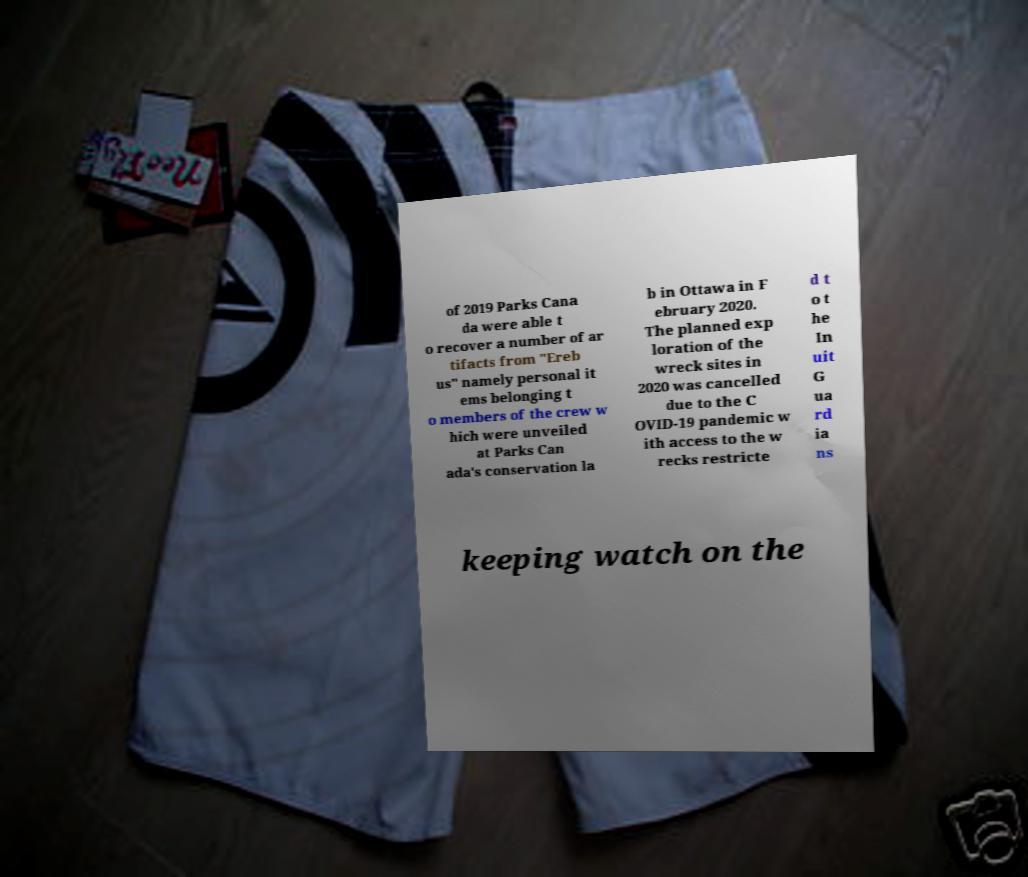Could you assist in decoding the text presented in this image and type it out clearly? of 2019 Parks Cana da were able t o recover a number of ar tifacts from "Ereb us" namely personal it ems belonging t o members of the crew w hich were unveiled at Parks Can ada's conservation la b in Ottawa in F ebruary 2020. The planned exp loration of the wreck sites in 2020 was cancelled due to the C OVID-19 pandemic w ith access to the w recks restricte d t o t he In uit G ua rd ia ns keeping watch on the 